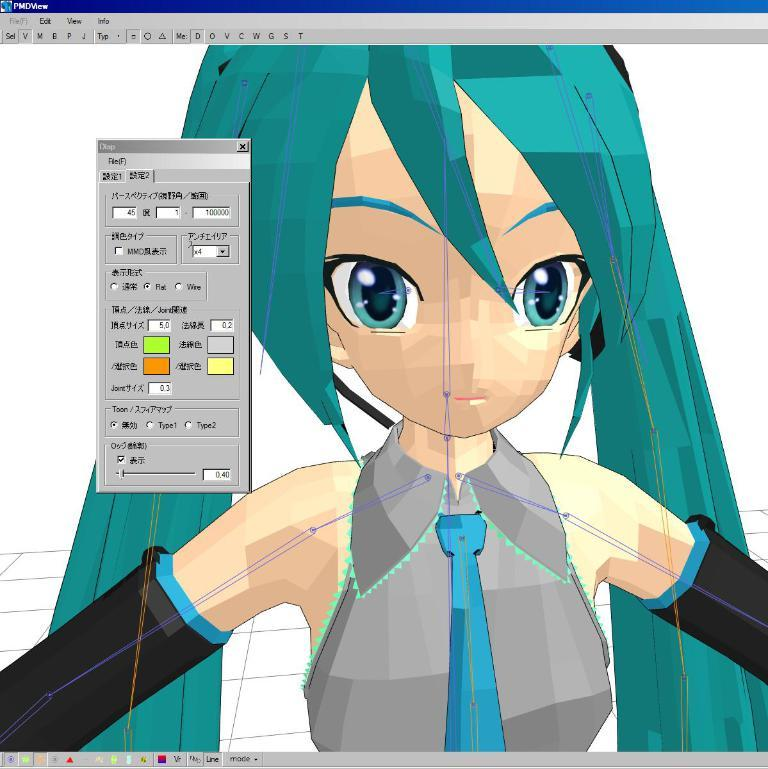What is the main subject of the picture? The main subject of the picture is an image of a girl. Can you describe any additional features or elements in the picture? Yes, there is a small tab beside the image of the girl. What type of gun is the girl holding in the image? There is no gun present in the image; it features an image of a girl with a small tab beside it. Can you tell me how many giraffes are visible in the image? There are no giraffes present in the image; it features an image of a girl with a small tab beside it. 